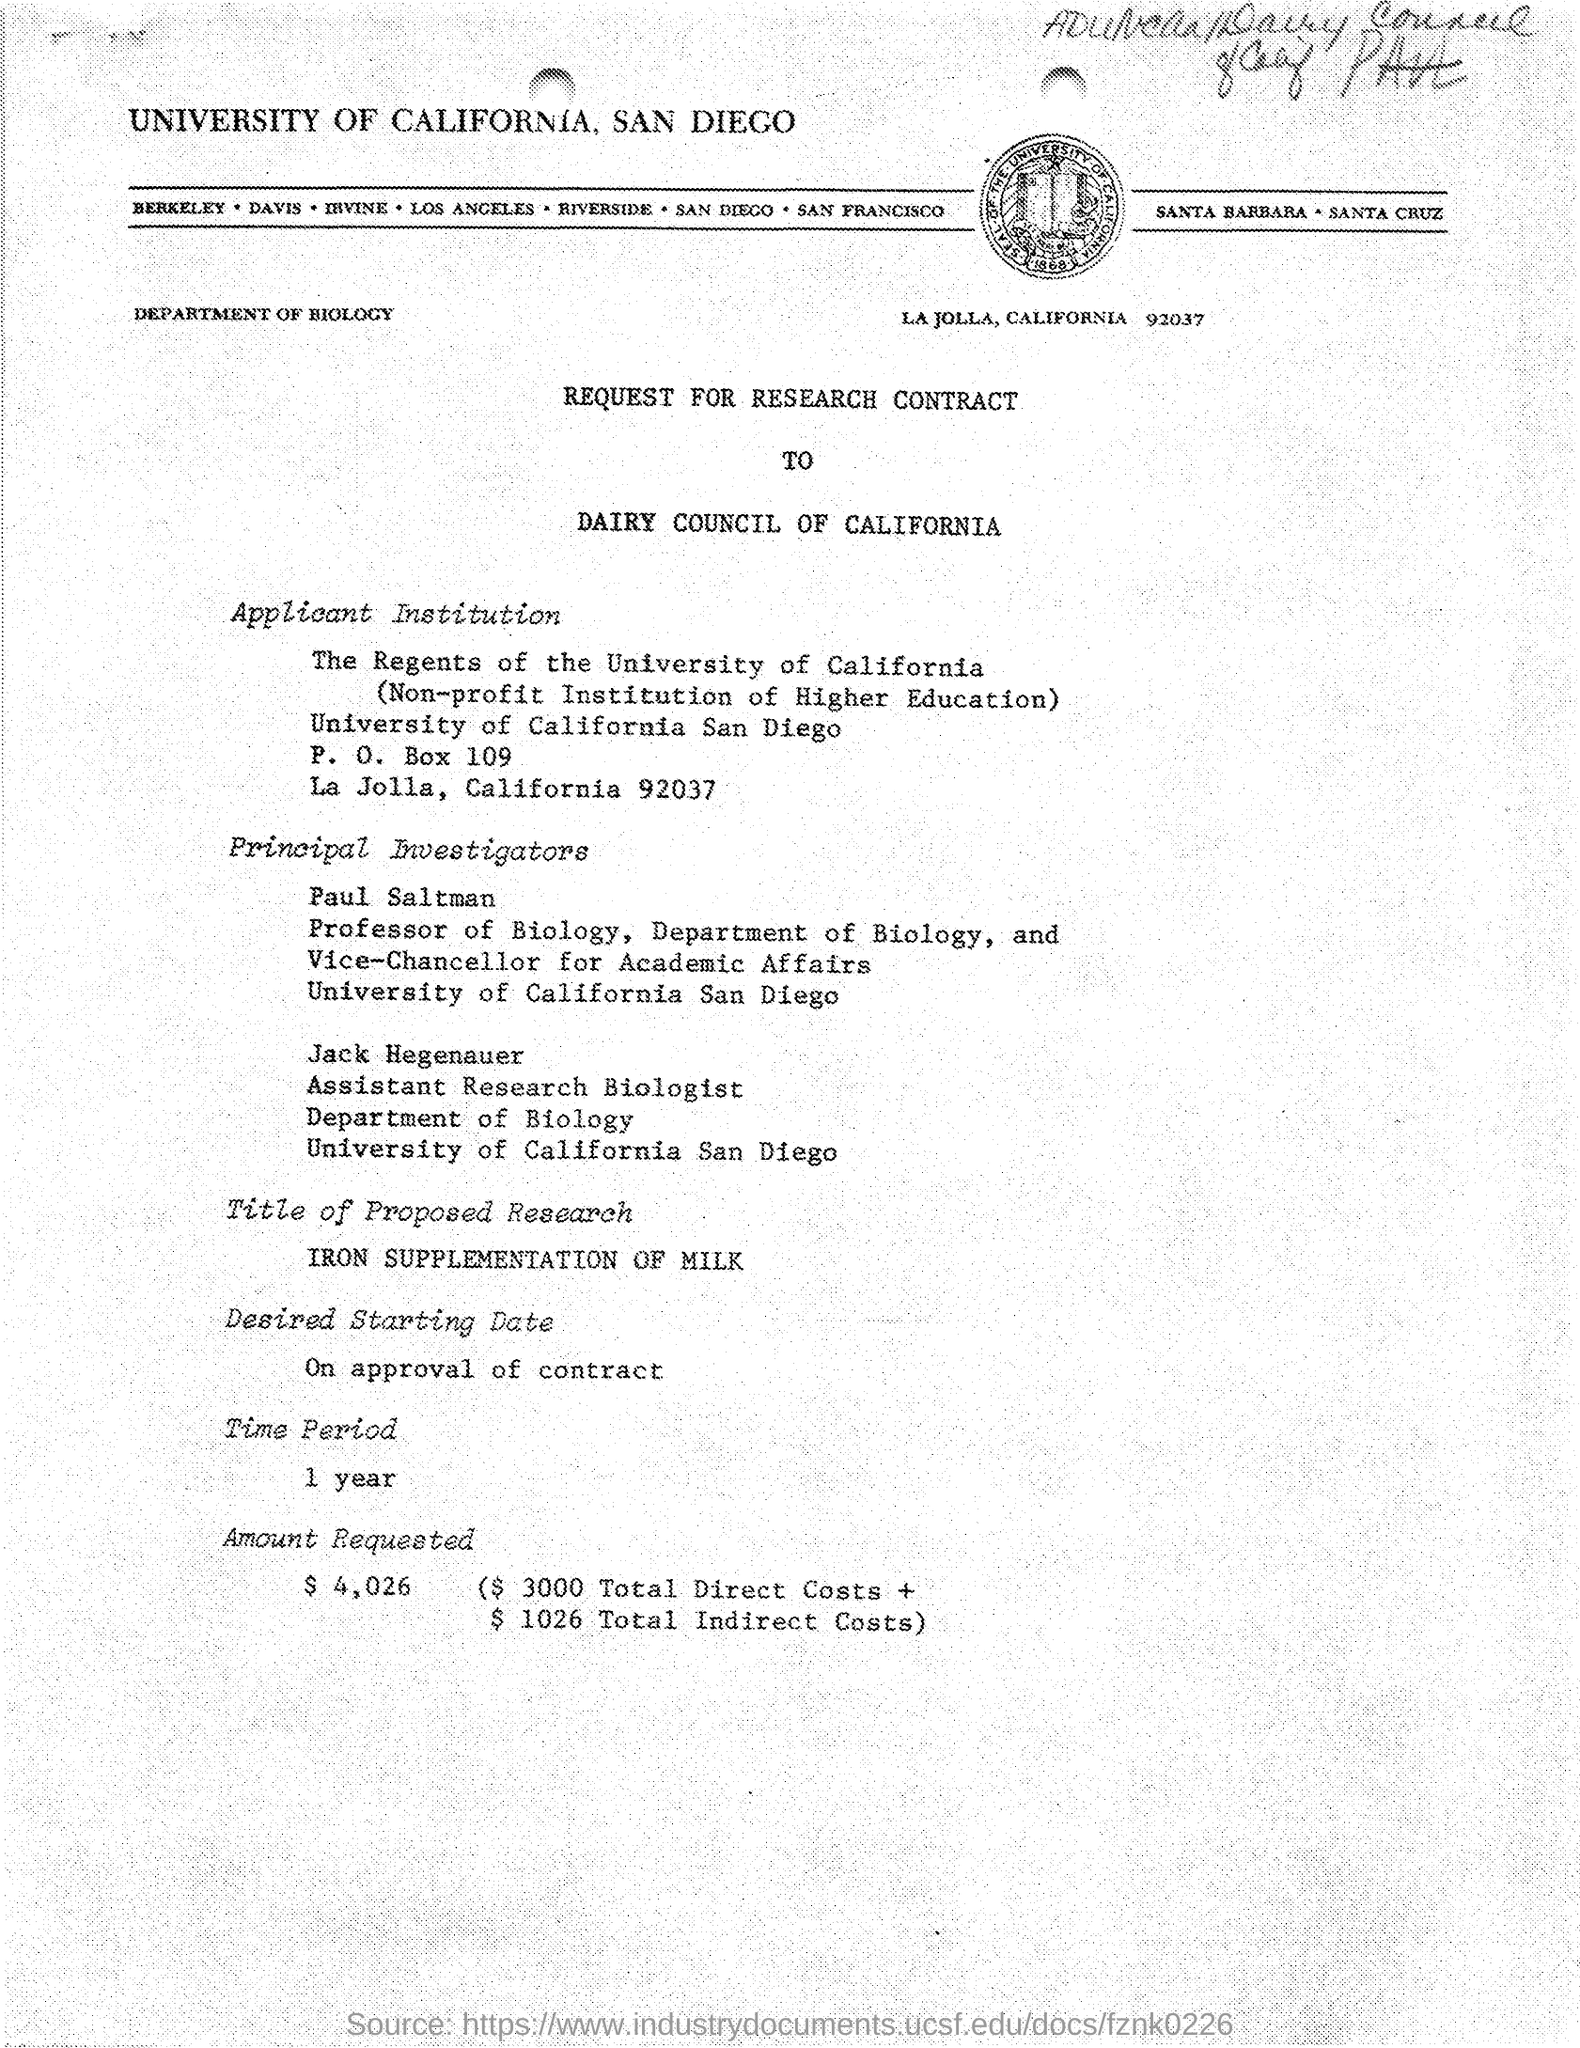Which is the Department?
Give a very brief answer. Department of Biology. What is the Title of Proposed Research?
Ensure brevity in your answer.  Iron Supplementation of Milk. When is the Desired Starting Date?
Give a very brief answer. On approval of contract. What is the Time Period?
Provide a succinct answer. 1 year. What is the Amount Requested?
Ensure brevity in your answer.  $4,026. What is Total Direct Costs?
Offer a very short reply. $3000. 